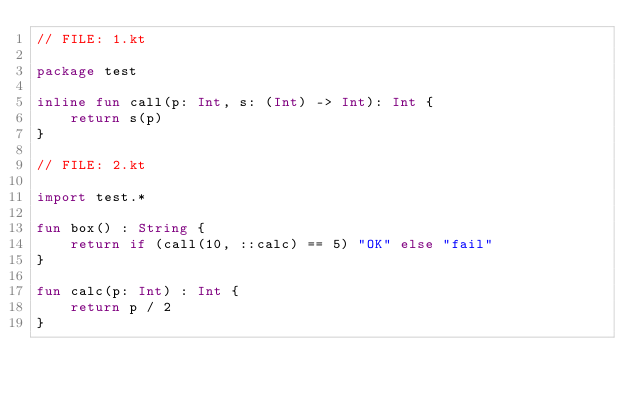<code> <loc_0><loc_0><loc_500><loc_500><_Kotlin_>// FILE: 1.kt

package test

inline fun call(p: Int, s: (Int) -> Int): Int {
    return s(p)
}

// FILE: 2.kt

import test.*

fun box() : String {
    return if (call(10, ::calc) == 5) "OK" else "fail"
}

fun calc(p: Int) : Int {
    return p / 2
}
</code> 